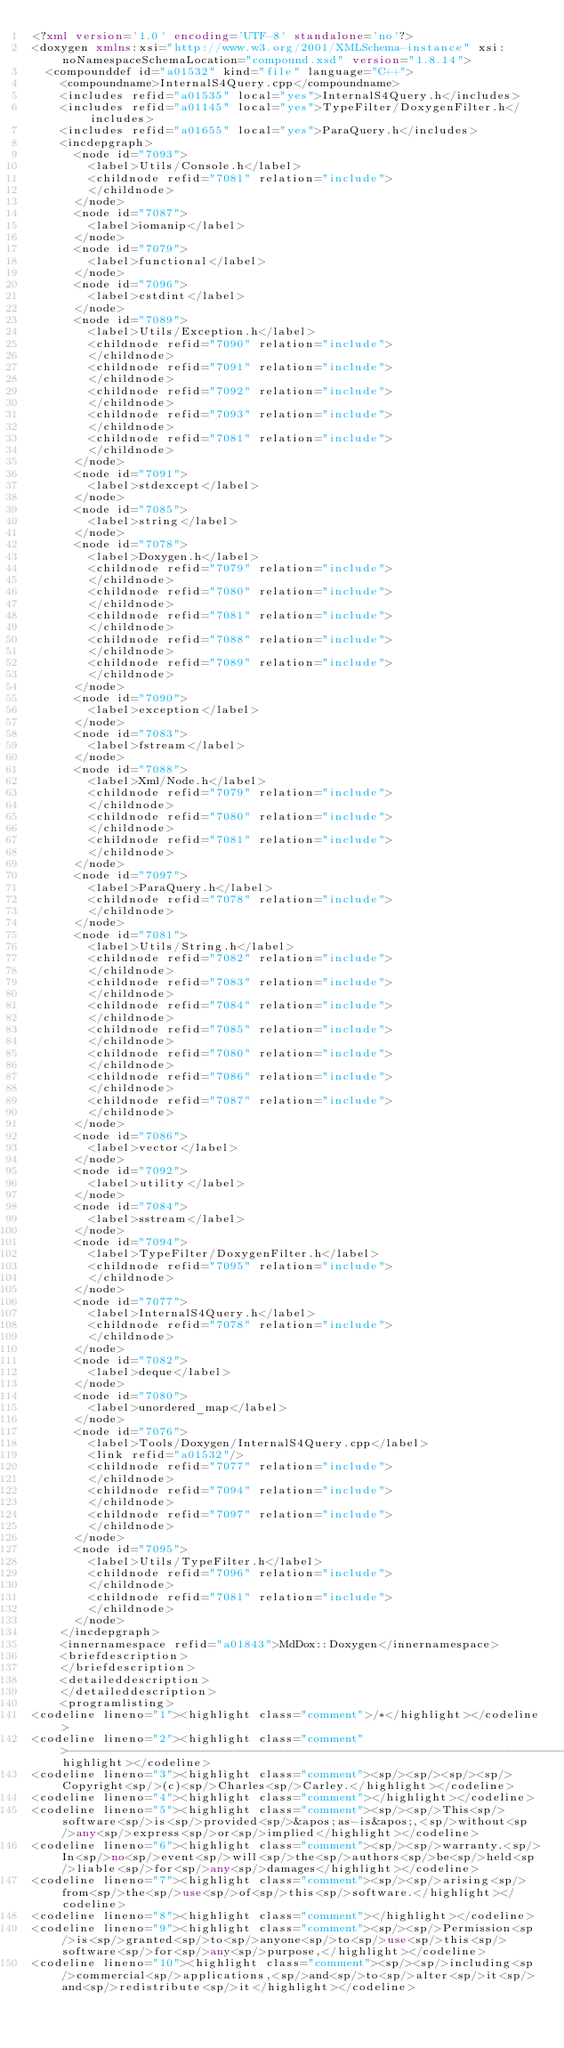<code> <loc_0><loc_0><loc_500><loc_500><_XML_><?xml version='1.0' encoding='UTF-8' standalone='no'?>
<doxygen xmlns:xsi="http://www.w3.org/2001/XMLSchema-instance" xsi:noNamespaceSchemaLocation="compound.xsd" version="1.8.14">
  <compounddef id="a01532" kind="file" language="C++">
    <compoundname>InternalS4Query.cpp</compoundname>
    <includes refid="a01535" local="yes">InternalS4Query.h</includes>
    <includes refid="a01145" local="yes">TypeFilter/DoxygenFilter.h</includes>
    <includes refid="a01655" local="yes">ParaQuery.h</includes>
    <incdepgraph>
      <node id="7093">
        <label>Utils/Console.h</label>
        <childnode refid="7081" relation="include">
        </childnode>
      </node>
      <node id="7087">
        <label>iomanip</label>
      </node>
      <node id="7079">
        <label>functional</label>
      </node>
      <node id="7096">
        <label>cstdint</label>
      </node>
      <node id="7089">
        <label>Utils/Exception.h</label>
        <childnode refid="7090" relation="include">
        </childnode>
        <childnode refid="7091" relation="include">
        </childnode>
        <childnode refid="7092" relation="include">
        </childnode>
        <childnode refid="7093" relation="include">
        </childnode>
        <childnode refid="7081" relation="include">
        </childnode>
      </node>
      <node id="7091">
        <label>stdexcept</label>
      </node>
      <node id="7085">
        <label>string</label>
      </node>
      <node id="7078">
        <label>Doxygen.h</label>
        <childnode refid="7079" relation="include">
        </childnode>
        <childnode refid="7080" relation="include">
        </childnode>
        <childnode refid="7081" relation="include">
        </childnode>
        <childnode refid="7088" relation="include">
        </childnode>
        <childnode refid="7089" relation="include">
        </childnode>
      </node>
      <node id="7090">
        <label>exception</label>
      </node>
      <node id="7083">
        <label>fstream</label>
      </node>
      <node id="7088">
        <label>Xml/Node.h</label>
        <childnode refid="7079" relation="include">
        </childnode>
        <childnode refid="7080" relation="include">
        </childnode>
        <childnode refid="7081" relation="include">
        </childnode>
      </node>
      <node id="7097">
        <label>ParaQuery.h</label>
        <childnode refid="7078" relation="include">
        </childnode>
      </node>
      <node id="7081">
        <label>Utils/String.h</label>
        <childnode refid="7082" relation="include">
        </childnode>
        <childnode refid="7083" relation="include">
        </childnode>
        <childnode refid="7084" relation="include">
        </childnode>
        <childnode refid="7085" relation="include">
        </childnode>
        <childnode refid="7080" relation="include">
        </childnode>
        <childnode refid="7086" relation="include">
        </childnode>
        <childnode refid="7087" relation="include">
        </childnode>
      </node>
      <node id="7086">
        <label>vector</label>
      </node>
      <node id="7092">
        <label>utility</label>
      </node>
      <node id="7084">
        <label>sstream</label>
      </node>
      <node id="7094">
        <label>TypeFilter/DoxygenFilter.h</label>
        <childnode refid="7095" relation="include">
        </childnode>
      </node>
      <node id="7077">
        <label>InternalS4Query.h</label>
        <childnode refid="7078" relation="include">
        </childnode>
      </node>
      <node id="7082">
        <label>deque</label>
      </node>
      <node id="7080">
        <label>unordered_map</label>
      </node>
      <node id="7076">
        <label>Tools/Doxygen/InternalS4Query.cpp</label>
        <link refid="a01532"/>
        <childnode refid="7077" relation="include">
        </childnode>
        <childnode refid="7094" relation="include">
        </childnode>
        <childnode refid="7097" relation="include">
        </childnode>
      </node>
      <node id="7095">
        <label>Utils/TypeFilter.h</label>
        <childnode refid="7096" relation="include">
        </childnode>
        <childnode refid="7081" relation="include">
        </childnode>
      </node>
    </incdepgraph>
    <innernamespace refid="a01843">MdDox::Doxygen</innernamespace>
    <briefdescription>
    </briefdescription>
    <detaileddescription>
    </detaileddescription>
    <programlisting>
<codeline lineno="1"><highlight class="comment">/*</highlight></codeline>
<codeline lineno="2"><highlight class="comment">-------------------------------------------------------------------------------</highlight></codeline>
<codeline lineno="3"><highlight class="comment"><sp/><sp/><sp/><sp/>Copyright<sp/>(c)<sp/>Charles<sp/>Carley.</highlight></codeline>
<codeline lineno="4"><highlight class="comment"></highlight></codeline>
<codeline lineno="5"><highlight class="comment"><sp/><sp/>This<sp/>software<sp/>is<sp/>provided<sp/>&apos;as-is&apos;,<sp/>without<sp/>any<sp/>express<sp/>or<sp/>implied</highlight></codeline>
<codeline lineno="6"><highlight class="comment"><sp/><sp/>warranty.<sp/>In<sp/>no<sp/>event<sp/>will<sp/>the<sp/>authors<sp/>be<sp/>held<sp/>liable<sp/>for<sp/>any<sp/>damages</highlight></codeline>
<codeline lineno="7"><highlight class="comment"><sp/><sp/>arising<sp/>from<sp/>the<sp/>use<sp/>of<sp/>this<sp/>software.</highlight></codeline>
<codeline lineno="8"><highlight class="comment"></highlight></codeline>
<codeline lineno="9"><highlight class="comment"><sp/><sp/>Permission<sp/>is<sp/>granted<sp/>to<sp/>anyone<sp/>to<sp/>use<sp/>this<sp/>software<sp/>for<sp/>any<sp/>purpose,</highlight></codeline>
<codeline lineno="10"><highlight class="comment"><sp/><sp/>including<sp/>commercial<sp/>applications,<sp/>and<sp/>to<sp/>alter<sp/>it<sp/>and<sp/>redistribute<sp/>it</highlight></codeline></code> 